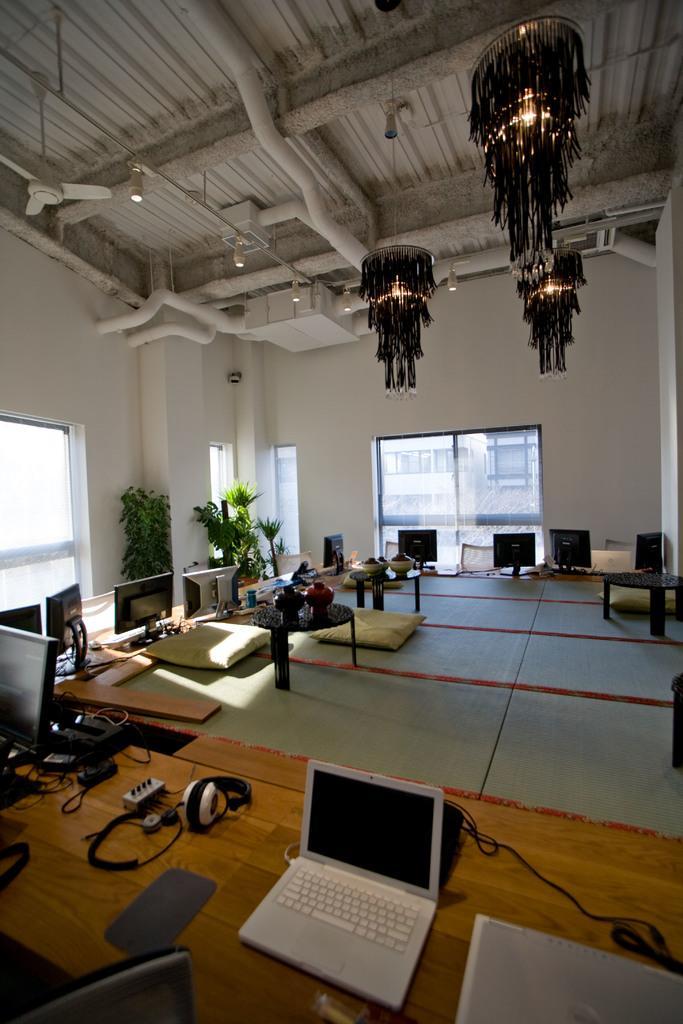Can you describe this image briefly? In this picture we can see a room with tables and on table we have headsets, laptop, wires and in background we can see wall with pillar, windows, trees, chandelier and from windows we can see buildings and here on table we can see pots. 